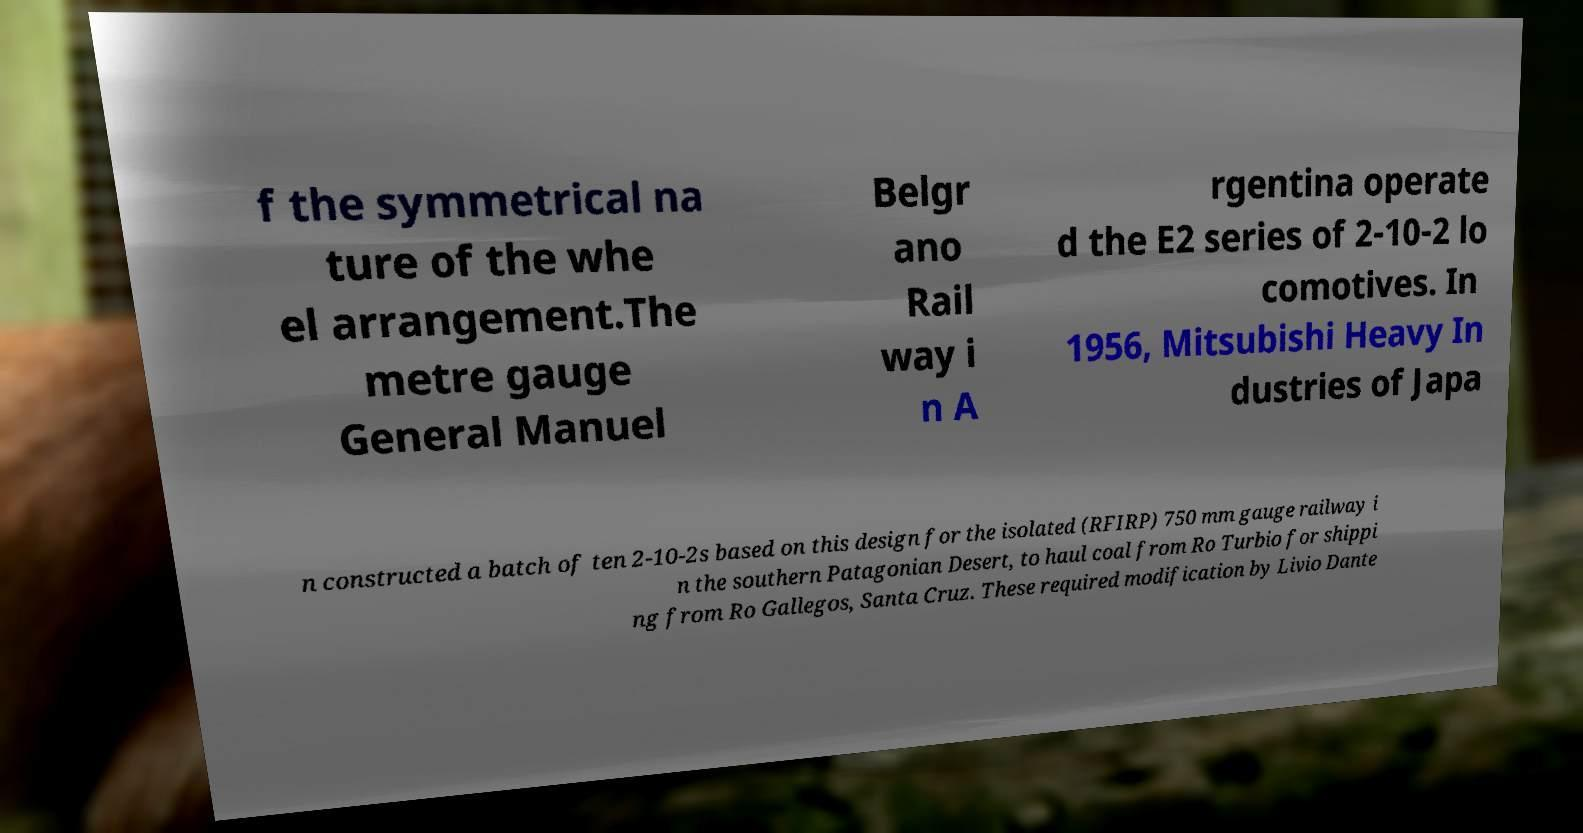Can you read and provide the text displayed in the image?This photo seems to have some interesting text. Can you extract and type it out for me? f the symmetrical na ture of the whe el arrangement.The metre gauge General Manuel Belgr ano Rail way i n A rgentina operate d the E2 series of 2-10-2 lo comotives. In 1956, Mitsubishi Heavy In dustries of Japa n constructed a batch of ten 2-10-2s based on this design for the isolated (RFIRP) 750 mm gauge railway i n the southern Patagonian Desert, to haul coal from Ro Turbio for shippi ng from Ro Gallegos, Santa Cruz. These required modification by Livio Dante 